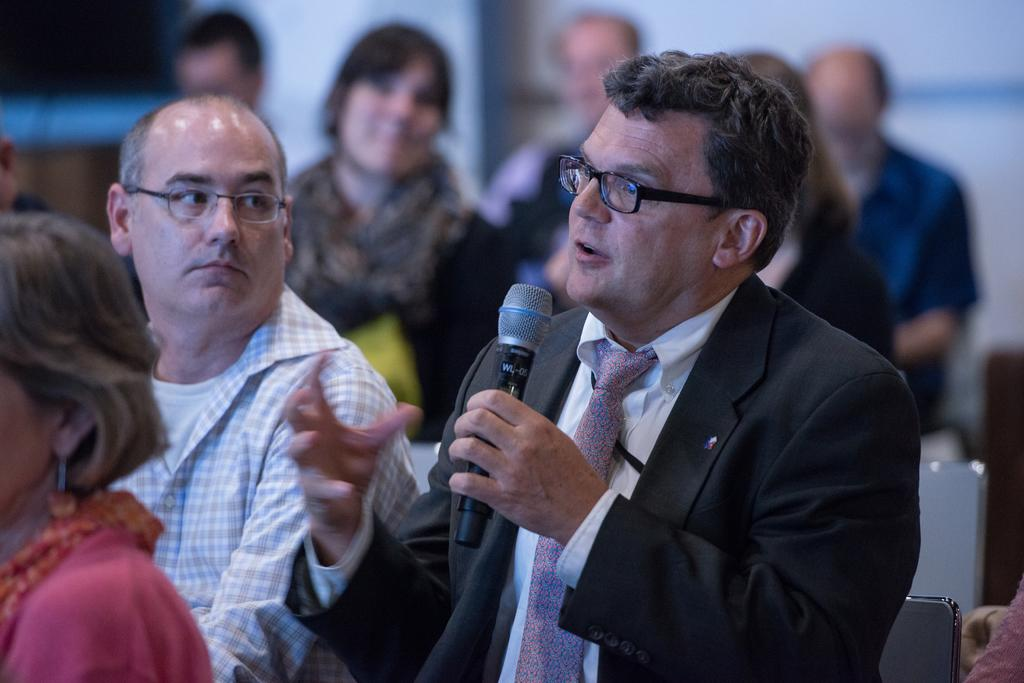Who is the main subject in the image? There is a man in the image. What is the man doing in the image? The man is speaking in the image. How is the man amplifying his voice in the image? The man is using a microphone in the image. What is the position of the man in the image? The man is seated in the image. Who else is present in the image? There are people in the image. What are the people doing in the image? The people are seated and watching the man in the image. What type of apparel is the band wearing in the image? There is no band present in the image, so we cannot determine the type of apparel they might be wearing. 